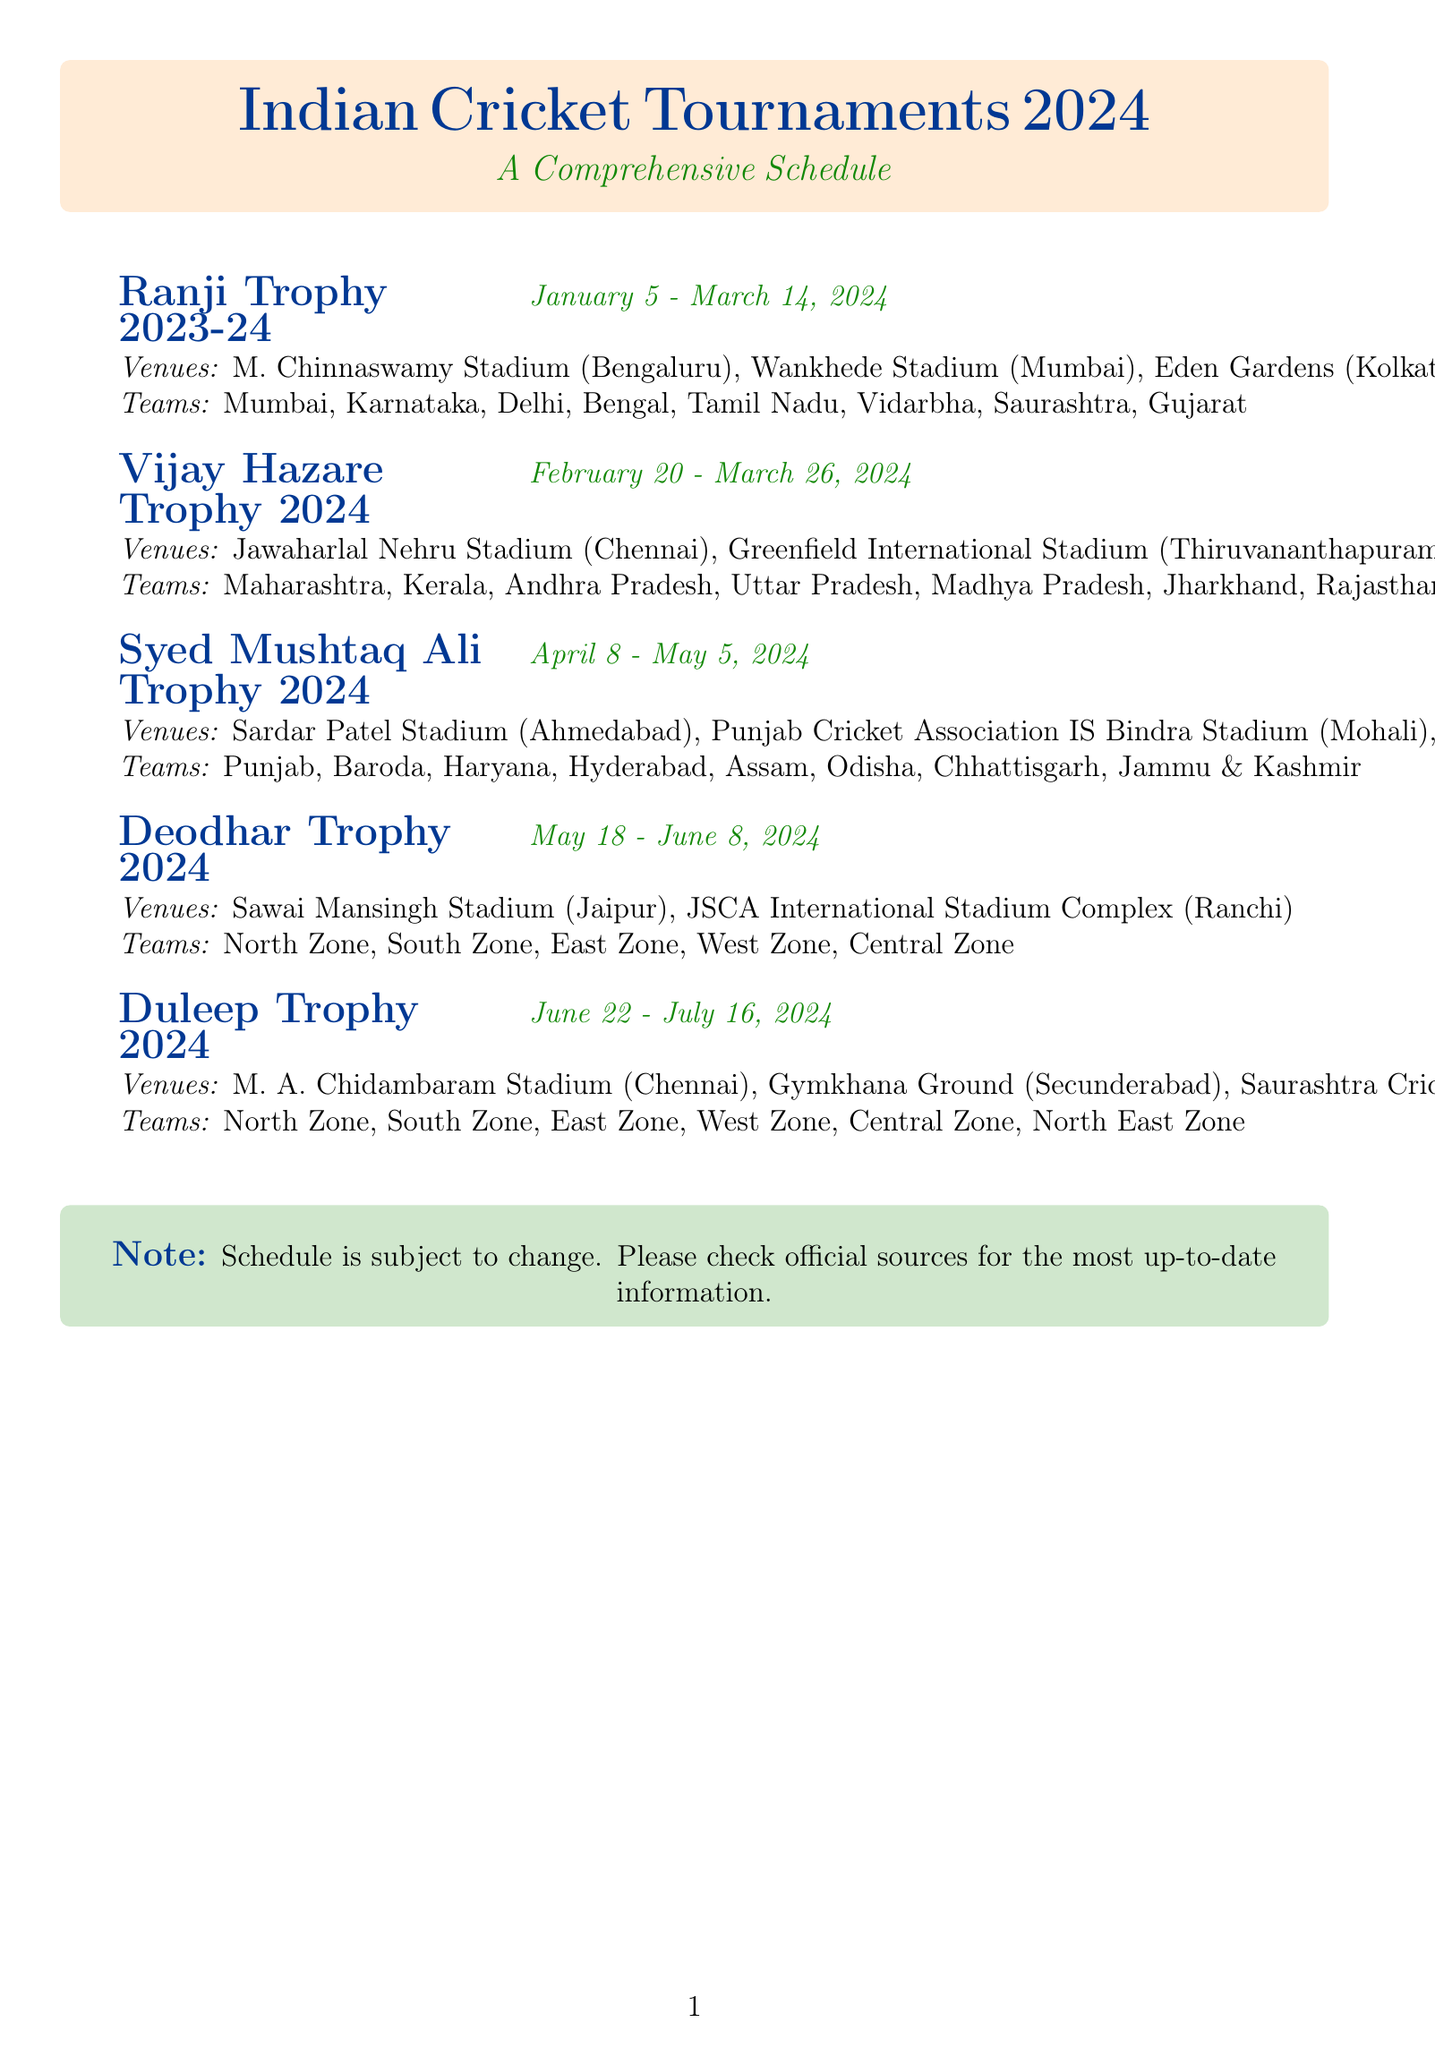what is the duration of the Ranji Trophy 2023-24? The duration of the Ranji Trophy 2023-24 is specified in the document as January 5 - March 14, 2024.
Answer: January 5 - March 14, 2024 how many teams are participating in the Vijay Hazare Trophy 2024? The number of teams is indicated in the tournament details for Vijay Hazare Trophy 2024, which lists eight teams.
Answer: 8 what is one of the venues for the Syed Mushtaq Ali Trophy 2024? One of the venues can be found in the tournament details for Syed Mushtaq Ali Trophy 2024, where Sardar Patel Stadium, Ahmedabad is mentioned.
Answer: Sardar Patel Stadium, Ahmedabad which teams will play in the Deodhar Trophy 2024? The teams playing in the Deodhar Trophy 2024 include various zones, as listed in the document, specifically named teams.
Answer: North Zone, South Zone, East Zone, West Zone, Central Zone when does the Duleep Trophy 2024 start? The starting date for the Duleep Trophy 2024 is provided in the document detailing the tournament's schedule.
Answer: June 22, 2024 which is the venue located in Mumbai for the Ranji Trophy 2023-24? The detailed venues for the Ranji Trophy 2023-24 include information about the stadiums, identifying Wankhede Stadium as the one in Mumbai.
Answer: Wankhede Stadium how many venues are listed for the Vijay Hazare Trophy 2024? The venues listed for this tournament totals three, as designated in the provided schedule.
Answer: 3 which tournament occurs first in 2024 based on the schedule? The document clearly outlines the occurrences of the tournaments with dates, where the Ranji Trophy 2023-24 starts first.
Answer: Ranji Trophy 2023-24 